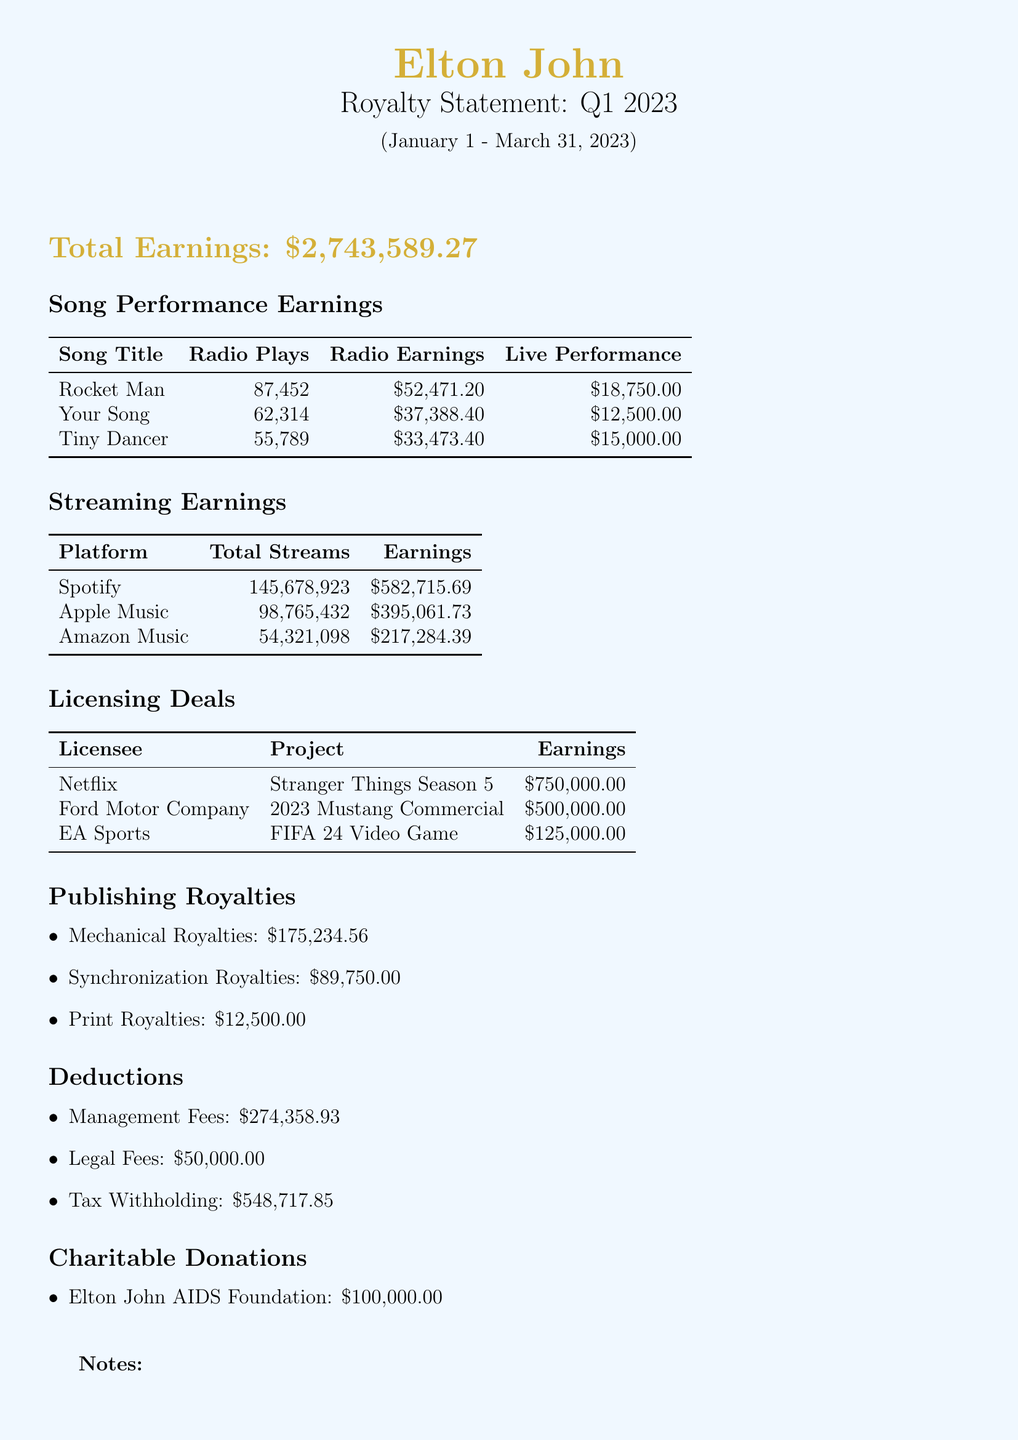what is the total earnings for Q1 2023? The total earnings is explicitly stated in the document as $2,743,589.27.
Answer: $2,743,589.27 how many radio plays did "Rocket Man" have? The number of radio plays for "Rocket Man" is specified in the song performance earnings section.
Answer: 87,452 what are the total streams on Spotify? The total streams for Spotify can be found in the streaming earnings section.
Answer: 145,678,923 which song was used in the Netflix project? The song used in the Netflix project, as listed under licensing deals, is "Don't Go Breaking My Heart."
Answer: Don't Go Breaking My Heart what is the total earnings from licensing deals? To find the total earnings from licensing deals, sum the specific amounts listed for each licensee.
Answer: $1,375,000.00 what is the amount donated to the Elton John AIDS Foundation? The charitable donation amount to the Elton John AIDS Foundation is provided in the document.
Answer: $100,000.00 how much did management fees amount to? The management fees are listed under deductions, providing the total amount.
Answer: $274,358.93 what is noted about streaming revenue compared to the previous quarter? A note in the document highlights a significant increase in streaming revenue compared to the previous quarter.
Answer: Significant increase in streaming revenue who licensed "I'm Still Standing" for a commercial? The licensing deal section indicates that Ford Motor Company licensed "I'm Still Standing."
Answer: Ford Motor Company 